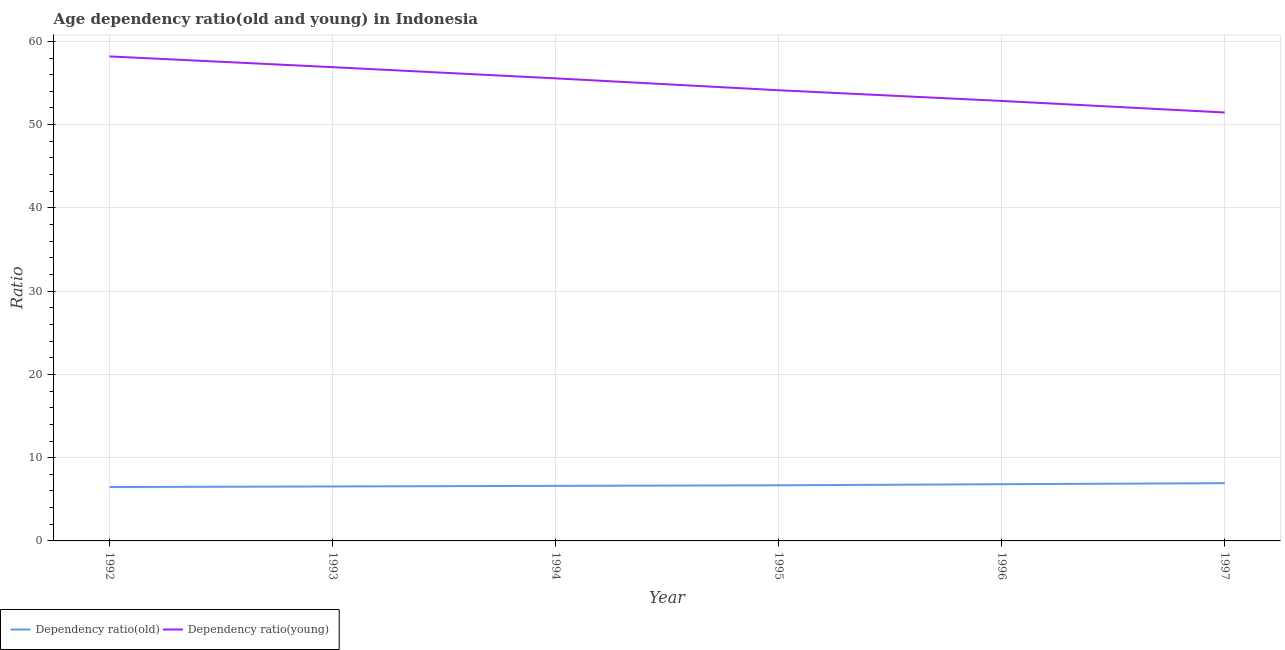How many different coloured lines are there?
Offer a very short reply. 2. Does the line corresponding to age dependency ratio(young) intersect with the line corresponding to age dependency ratio(old)?
Your answer should be compact. No. What is the age dependency ratio(old) in 1994?
Ensure brevity in your answer.  6.61. Across all years, what is the maximum age dependency ratio(young)?
Make the answer very short. 58.19. Across all years, what is the minimum age dependency ratio(young)?
Your response must be concise. 51.45. What is the total age dependency ratio(young) in the graph?
Provide a short and direct response. 329.08. What is the difference between the age dependency ratio(old) in 1993 and that in 1996?
Provide a succinct answer. -0.27. What is the difference between the age dependency ratio(young) in 1993 and the age dependency ratio(old) in 1992?
Keep it short and to the point. 50.43. What is the average age dependency ratio(old) per year?
Provide a short and direct response. 6.68. In the year 1993, what is the difference between the age dependency ratio(young) and age dependency ratio(old)?
Your answer should be compact. 50.36. What is the ratio of the age dependency ratio(old) in 1995 to that in 1997?
Provide a short and direct response. 0.96. Is the age dependency ratio(young) in 1996 less than that in 1997?
Offer a terse response. No. What is the difference between the highest and the second highest age dependency ratio(old)?
Provide a succinct answer. 0.12. What is the difference between the highest and the lowest age dependency ratio(young)?
Provide a succinct answer. 6.74. Does the age dependency ratio(young) monotonically increase over the years?
Ensure brevity in your answer.  No. How many lines are there?
Your response must be concise. 2. How many years are there in the graph?
Give a very brief answer. 6. Does the graph contain any zero values?
Your response must be concise. No. What is the title of the graph?
Offer a very short reply. Age dependency ratio(old and young) in Indonesia. Does "GDP" appear as one of the legend labels in the graph?
Ensure brevity in your answer.  No. What is the label or title of the X-axis?
Provide a succinct answer. Year. What is the label or title of the Y-axis?
Provide a short and direct response. Ratio. What is the Ratio in Dependency ratio(old) in 1992?
Keep it short and to the point. 6.47. What is the Ratio of Dependency ratio(young) in 1992?
Your response must be concise. 58.19. What is the Ratio in Dependency ratio(old) in 1993?
Offer a terse response. 6.54. What is the Ratio of Dependency ratio(young) in 1993?
Keep it short and to the point. 56.9. What is the Ratio of Dependency ratio(old) in 1994?
Offer a very short reply. 6.61. What is the Ratio of Dependency ratio(young) in 1994?
Make the answer very short. 55.56. What is the Ratio in Dependency ratio(old) in 1995?
Your answer should be compact. 6.68. What is the Ratio in Dependency ratio(young) in 1995?
Ensure brevity in your answer.  54.13. What is the Ratio in Dependency ratio(old) in 1996?
Give a very brief answer. 6.81. What is the Ratio in Dependency ratio(young) in 1996?
Provide a succinct answer. 52.84. What is the Ratio in Dependency ratio(old) in 1997?
Offer a terse response. 6.93. What is the Ratio in Dependency ratio(young) in 1997?
Ensure brevity in your answer.  51.45. Across all years, what is the maximum Ratio in Dependency ratio(old)?
Offer a very short reply. 6.93. Across all years, what is the maximum Ratio of Dependency ratio(young)?
Make the answer very short. 58.19. Across all years, what is the minimum Ratio of Dependency ratio(old)?
Make the answer very short. 6.47. Across all years, what is the minimum Ratio in Dependency ratio(young)?
Keep it short and to the point. 51.45. What is the total Ratio of Dependency ratio(old) in the graph?
Provide a short and direct response. 40.05. What is the total Ratio of Dependency ratio(young) in the graph?
Give a very brief answer. 329.08. What is the difference between the Ratio in Dependency ratio(old) in 1992 and that in 1993?
Your answer should be compact. -0.07. What is the difference between the Ratio of Dependency ratio(young) in 1992 and that in 1993?
Provide a short and direct response. 1.29. What is the difference between the Ratio in Dependency ratio(old) in 1992 and that in 1994?
Give a very brief answer. -0.14. What is the difference between the Ratio in Dependency ratio(young) in 1992 and that in 1994?
Your response must be concise. 2.63. What is the difference between the Ratio in Dependency ratio(old) in 1992 and that in 1995?
Your answer should be compact. -0.21. What is the difference between the Ratio of Dependency ratio(young) in 1992 and that in 1995?
Your answer should be compact. 4.06. What is the difference between the Ratio in Dependency ratio(old) in 1992 and that in 1996?
Provide a short and direct response. -0.34. What is the difference between the Ratio of Dependency ratio(young) in 1992 and that in 1996?
Your answer should be very brief. 5.35. What is the difference between the Ratio of Dependency ratio(old) in 1992 and that in 1997?
Your answer should be compact. -0.46. What is the difference between the Ratio in Dependency ratio(young) in 1992 and that in 1997?
Your answer should be compact. 6.74. What is the difference between the Ratio of Dependency ratio(old) in 1993 and that in 1994?
Offer a terse response. -0.07. What is the difference between the Ratio of Dependency ratio(young) in 1993 and that in 1994?
Provide a succinct answer. 1.34. What is the difference between the Ratio in Dependency ratio(old) in 1993 and that in 1995?
Provide a succinct answer. -0.14. What is the difference between the Ratio of Dependency ratio(young) in 1993 and that in 1995?
Your answer should be very brief. 2.77. What is the difference between the Ratio in Dependency ratio(old) in 1993 and that in 1996?
Provide a succinct answer. -0.27. What is the difference between the Ratio in Dependency ratio(young) in 1993 and that in 1996?
Your answer should be very brief. 4.06. What is the difference between the Ratio in Dependency ratio(old) in 1993 and that in 1997?
Ensure brevity in your answer.  -0.39. What is the difference between the Ratio of Dependency ratio(young) in 1993 and that in 1997?
Keep it short and to the point. 5.45. What is the difference between the Ratio of Dependency ratio(old) in 1994 and that in 1995?
Provide a short and direct response. -0.07. What is the difference between the Ratio of Dependency ratio(young) in 1994 and that in 1995?
Your answer should be compact. 1.43. What is the difference between the Ratio in Dependency ratio(old) in 1994 and that in 1996?
Your answer should be very brief. -0.2. What is the difference between the Ratio of Dependency ratio(young) in 1994 and that in 1996?
Your answer should be compact. 2.71. What is the difference between the Ratio in Dependency ratio(old) in 1994 and that in 1997?
Offer a terse response. -0.32. What is the difference between the Ratio in Dependency ratio(young) in 1994 and that in 1997?
Offer a very short reply. 4.1. What is the difference between the Ratio of Dependency ratio(old) in 1995 and that in 1996?
Offer a terse response. -0.13. What is the difference between the Ratio in Dependency ratio(young) in 1995 and that in 1996?
Provide a short and direct response. 1.28. What is the difference between the Ratio of Dependency ratio(old) in 1995 and that in 1997?
Your response must be concise. -0.25. What is the difference between the Ratio of Dependency ratio(young) in 1995 and that in 1997?
Provide a short and direct response. 2.67. What is the difference between the Ratio in Dependency ratio(old) in 1996 and that in 1997?
Offer a terse response. -0.12. What is the difference between the Ratio of Dependency ratio(young) in 1996 and that in 1997?
Your answer should be very brief. 1.39. What is the difference between the Ratio of Dependency ratio(old) in 1992 and the Ratio of Dependency ratio(young) in 1993?
Offer a terse response. -50.43. What is the difference between the Ratio of Dependency ratio(old) in 1992 and the Ratio of Dependency ratio(young) in 1994?
Your answer should be very brief. -49.09. What is the difference between the Ratio in Dependency ratio(old) in 1992 and the Ratio in Dependency ratio(young) in 1995?
Your answer should be very brief. -47.66. What is the difference between the Ratio in Dependency ratio(old) in 1992 and the Ratio in Dependency ratio(young) in 1996?
Offer a terse response. -46.37. What is the difference between the Ratio in Dependency ratio(old) in 1992 and the Ratio in Dependency ratio(young) in 1997?
Give a very brief answer. -44.98. What is the difference between the Ratio of Dependency ratio(old) in 1993 and the Ratio of Dependency ratio(young) in 1994?
Keep it short and to the point. -49.02. What is the difference between the Ratio of Dependency ratio(old) in 1993 and the Ratio of Dependency ratio(young) in 1995?
Offer a terse response. -47.59. What is the difference between the Ratio in Dependency ratio(old) in 1993 and the Ratio in Dependency ratio(young) in 1996?
Make the answer very short. -46.3. What is the difference between the Ratio in Dependency ratio(old) in 1993 and the Ratio in Dependency ratio(young) in 1997?
Keep it short and to the point. -44.91. What is the difference between the Ratio in Dependency ratio(old) in 1994 and the Ratio in Dependency ratio(young) in 1995?
Provide a short and direct response. -47.52. What is the difference between the Ratio of Dependency ratio(old) in 1994 and the Ratio of Dependency ratio(young) in 1996?
Your response must be concise. -46.23. What is the difference between the Ratio in Dependency ratio(old) in 1994 and the Ratio in Dependency ratio(young) in 1997?
Keep it short and to the point. -44.84. What is the difference between the Ratio of Dependency ratio(old) in 1995 and the Ratio of Dependency ratio(young) in 1996?
Your answer should be very brief. -46.16. What is the difference between the Ratio of Dependency ratio(old) in 1995 and the Ratio of Dependency ratio(young) in 1997?
Provide a succinct answer. -44.77. What is the difference between the Ratio of Dependency ratio(old) in 1996 and the Ratio of Dependency ratio(young) in 1997?
Give a very brief answer. -44.64. What is the average Ratio in Dependency ratio(old) per year?
Your answer should be compact. 6.68. What is the average Ratio in Dependency ratio(young) per year?
Your answer should be very brief. 54.85. In the year 1992, what is the difference between the Ratio in Dependency ratio(old) and Ratio in Dependency ratio(young)?
Keep it short and to the point. -51.72. In the year 1993, what is the difference between the Ratio in Dependency ratio(old) and Ratio in Dependency ratio(young)?
Offer a terse response. -50.36. In the year 1994, what is the difference between the Ratio of Dependency ratio(old) and Ratio of Dependency ratio(young)?
Your response must be concise. -48.95. In the year 1995, what is the difference between the Ratio of Dependency ratio(old) and Ratio of Dependency ratio(young)?
Provide a succinct answer. -47.45. In the year 1996, what is the difference between the Ratio of Dependency ratio(old) and Ratio of Dependency ratio(young)?
Offer a very short reply. -46.03. In the year 1997, what is the difference between the Ratio in Dependency ratio(old) and Ratio in Dependency ratio(young)?
Give a very brief answer. -44.52. What is the ratio of the Ratio in Dependency ratio(young) in 1992 to that in 1993?
Give a very brief answer. 1.02. What is the ratio of the Ratio in Dependency ratio(old) in 1992 to that in 1994?
Make the answer very short. 0.98. What is the ratio of the Ratio in Dependency ratio(young) in 1992 to that in 1994?
Give a very brief answer. 1.05. What is the ratio of the Ratio of Dependency ratio(old) in 1992 to that in 1995?
Offer a terse response. 0.97. What is the ratio of the Ratio of Dependency ratio(young) in 1992 to that in 1995?
Keep it short and to the point. 1.08. What is the ratio of the Ratio of Dependency ratio(old) in 1992 to that in 1996?
Provide a short and direct response. 0.95. What is the ratio of the Ratio of Dependency ratio(young) in 1992 to that in 1996?
Your response must be concise. 1.1. What is the ratio of the Ratio in Dependency ratio(old) in 1992 to that in 1997?
Offer a very short reply. 0.93. What is the ratio of the Ratio in Dependency ratio(young) in 1992 to that in 1997?
Offer a very short reply. 1.13. What is the ratio of the Ratio of Dependency ratio(young) in 1993 to that in 1994?
Offer a terse response. 1.02. What is the ratio of the Ratio of Dependency ratio(old) in 1993 to that in 1995?
Keep it short and to the point. 0.98. What is the ratio of the Ratio in Dependency ratio(young) in 1993 to that in 1995?
Your response must be concise. 1.05. What is the ratio of the Ratio in Dependency ratio(old) in 1993 to that in 1996?
Provide a short and direct response. 0.96. What is the ratio of the Ratio in Dependency ratio(young) in 1993 to that in 1996?
Give a very brief answer. 1.08. What is the ratio of the Ratio in Dependency ratio(old) in 1993 to that in 1997?
Offer a terse response. 0.94. What is the ratio of the Ratio of Dependency ratio(young) in 1993 to that in 1997?
Offer a very short reply. 1.11. What is the ratio of the Ratio of Dependency ratio(young) in 1994 to that in 1995?
Provide a short and direct response. 1.03. What is the ratio of the Ratio of Dependency ratio(old) in 1994 to that in 1996?
Make the answer very short. 0.97. What is the ratio of the Ratio in Dependency ratio(young) in 1994 to that in 1996?
Keep it short and to the point. 1.05. What is the ratio of the Ratio of Dependency ratio(old) in 1994 to that in 1997?
Make the answer very short. 0.95. What is the ratio of the Ratio in Dependency ratio(young) in 1994 to that in 1997?
Give a very brief answer. 1.08. What is the ratio of the Ratio in Dependency ratio(old) in 1995 to that in 1996?
Provide a succinct answer. 0.98. What is the ratio of the Ratio in Dependency ratio(young) in 1995 to that in 1996?
Your answer should be compact. 1.02. What is the ratio of the Ratio of Dependency ratio(old) in 1995 to that in 1997?
Ensure brevity in your answer.  0.96. What is the ratio of the Ratio in Dependency ratio(young) in 1995 to that in 1997?
Ensure brevity in your answer.  1.05. What is the ratio of the Ratio of Dependency ratio(old) in 1996 to that in 1997?
Provide a short and direct response. 0.98. What is the ratio of the Ratio of Dependency ratio(young) in 1996 to that in 1997?
Offer a very short reply. 1.03. What is the difference between the highest and the second highest Ratio in Dependency ratio(old)?
Your response must be concise. 0.12. What is the difference between the highest and the second highest Ratio in Dependency ratio(young)?
Your response must be concise. 1.29. What is the difference between the highest and the lowest Ratio of Dependency ratio(old)?
Your response must be concise. 0.46. What is the difference between the highest and the lowest Ratio of Dependency ratio(young)?
Your answer should be compact. 6.74. 